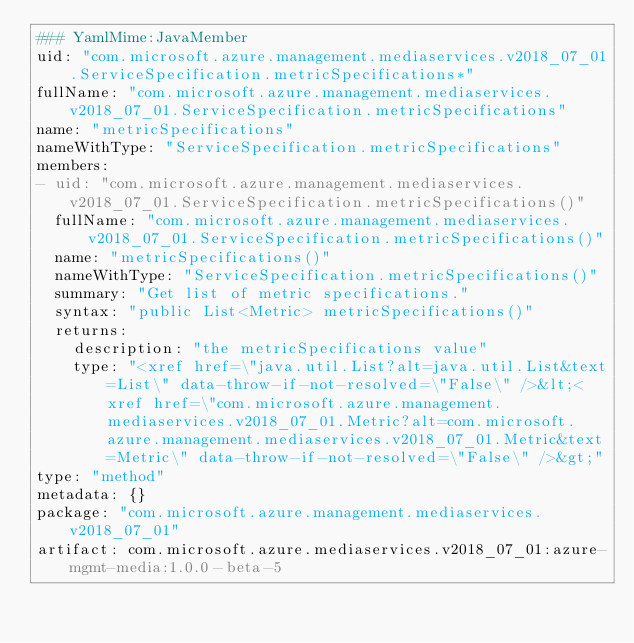Convert code to text. <code><loc_0><loc_0><loc_500><loc_500><_YAML_>### YamlMime:JavaMember
uid: "com.microsoft.azure.management.mediaservices.v2018_07_01.ServiceSpecification.metricSpecifications*"
fullName: "com.microsoft.azure.management.mediaservices.v2018_07_01.ServiceSpecification.metricSpecifications"
name: "metricSpecifications"
nameWithType: "ServiceSpecification.metricSpecifications"
members:
- uid: "com.microsoft.azure.management.mediaservices.v2018_07_01.ServiceSpecification.metricSpecifications()"
  fullName: "com.microsoft.azure.management.mediaservices.v2018_07_01.ServiceSpecification.metricSpecifications()"
  name: "metricSpecifications()"
  nameWithType: "ServiceSpecification.metricSpecifications()"
  summary: "Get list of metric specifications."
  syntax: "public List<Metric> metricSpecifications()"
  returns:
    description: "the metricSpecifications value"
    type: "<xref href=\"java.util.List?alt=java.util.List&text=List\" data-throw-if-not-resolved=\"False\" />&lt;<xref href=\"com.microsoft.azure.management.mediaservices.v2018_07_01.Metric?alt=com.microsoft.azure.management.mediaservices.v2018_07_01.Metric&text=Metric\" data-throw-if-not-resolved=\"False\" />&gt;"
type: "method"
metadata: {}
package: "com.microsoft.azure.management.mediaservices.v2018_07_01"
artifact: com.microsoft.azure.mediaservices.v2018_07_01:azure-mgmt-media:1.0.0-beta-5
</code> 